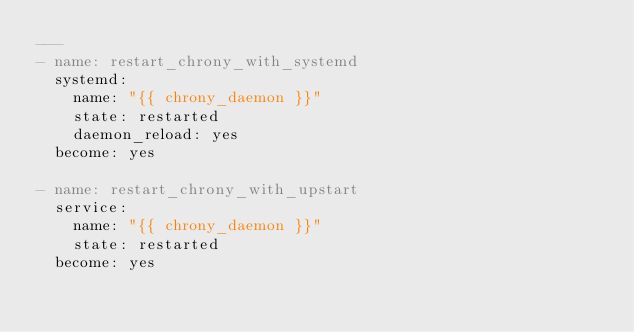Convert code to text. <code><loc_0><loc_0><loc_500><loc_500><_YAML_>---
- name: restart_chrony_with_systemd
  systemd:
    name: "{{ chrony_daemon }}"
    state: restarted
    daemon_reload: yes
  become: yes

- name: restart_chrony_with_upstart
  service:
    name: "{{ chrony_daemon }}"
    state: restarted
  become: yes
</code> 